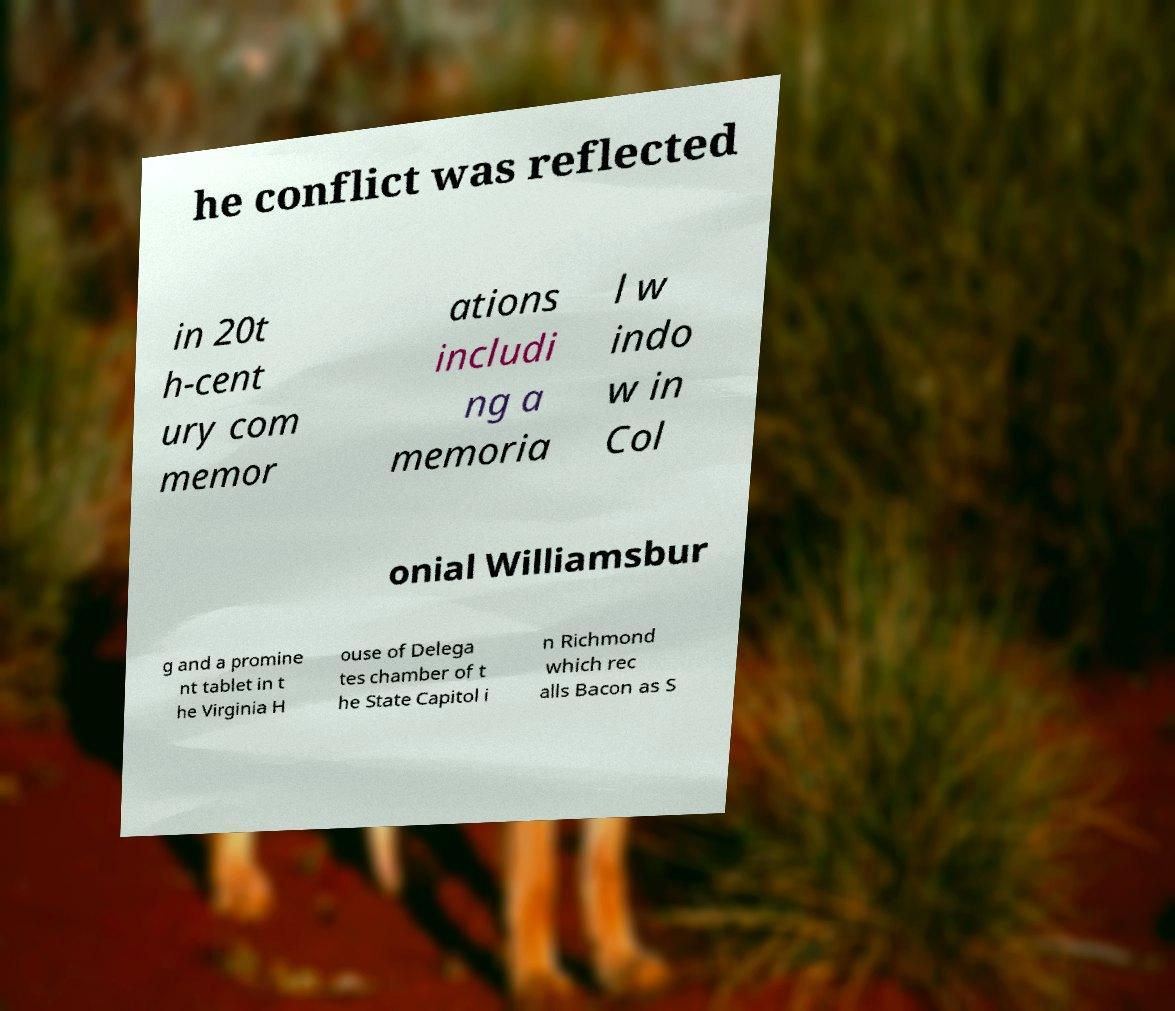There's text embedded in this image that I need extracted. Can you transcribe it verbatim? he conflict was reflected in 20t h-cent ury com memor ations includi ng a memoria l w indo w in Col onial Williamsbur g and a promine nt tablet in t he Virginia H ouse of Delega tes chamber of t he State Capitol i n Richmond which rec alls Bacon as S 